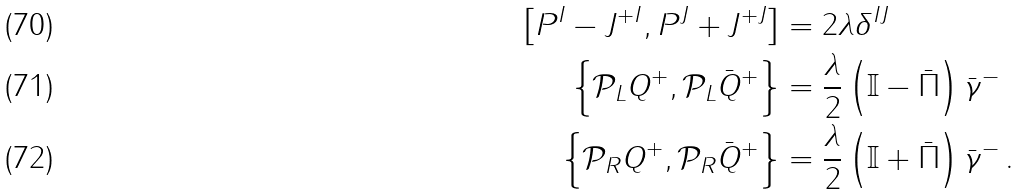Convert formula to latex. <formula><loc_0><loc_0><loc_500><loc_500>\left [ P ^ { I } - J ^ { + I } , P ^ { J } + J ^ { + J } \right ] & = 2 \lambda \delta ^ { I J } \\ \left \{ \mathcal { P } _ { L } { Q } ^ { + } , \mathcal { P } _ { L } \bar { Q } ^ { + } \right \} & = \frac { \lambda } { 2 } \left ( \mathbb { I } - \bar { \Pi } \right ) \bar { \gamma } ^ { - } \\ \left \{ \mathcal { P } _ { R } { Q } ^ { + } , \mathcal { P } _ { R } \bar { Q } ^ { + } \right \} & = \frac { \lambda } { 2 } \left ( \mathbb { I } + \bar { \Pi } \right ) \bar { \gamma } ^ { - } \, .</formula> 